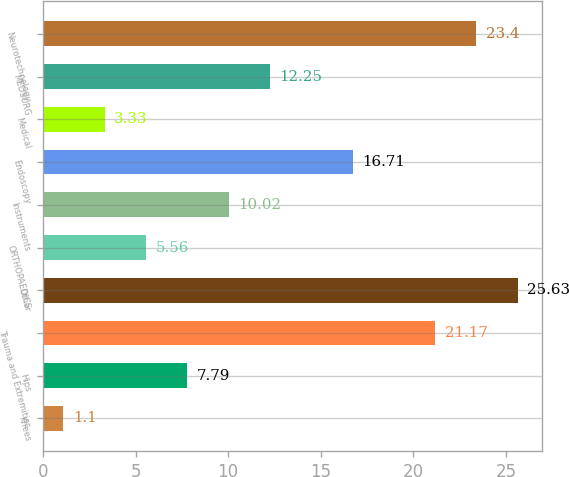Convert chart to OTSL. <chart><loc_0><loc_0><loc_500><loc_500><bar_chart><fcel>Knees<fcel>Hips<fcel>Trauma and Extremities<fcel>Other<fcel>ORTHOPAEDICS<fcel>Instruments<fcel>Endoscopy<fcel>Medical<fcel>MEDSURG<fcel>Neurotechnology<nl><fcel>1.1<fcel>7.79<fcel>21.17<fcel>25.63<fcel>5.56<fcel>10.02<fcel>16.71<fcel>3.33<fcel>12.25<fcel>23.4<nl></chart> 